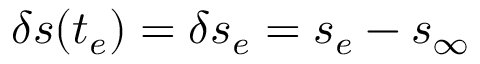<formula> <loc_0><loc_0><loc_500><loc_500>\delta s ( t _ { e } ) = \delta s _ { e } = s _ { e } - s _ { \infty }</formula> 